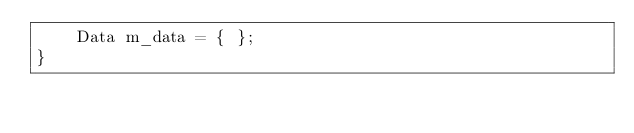<code> <loc_0><loc_0><loc_500><loc_500><_C++_>	Data m_data = { };
}</code> 